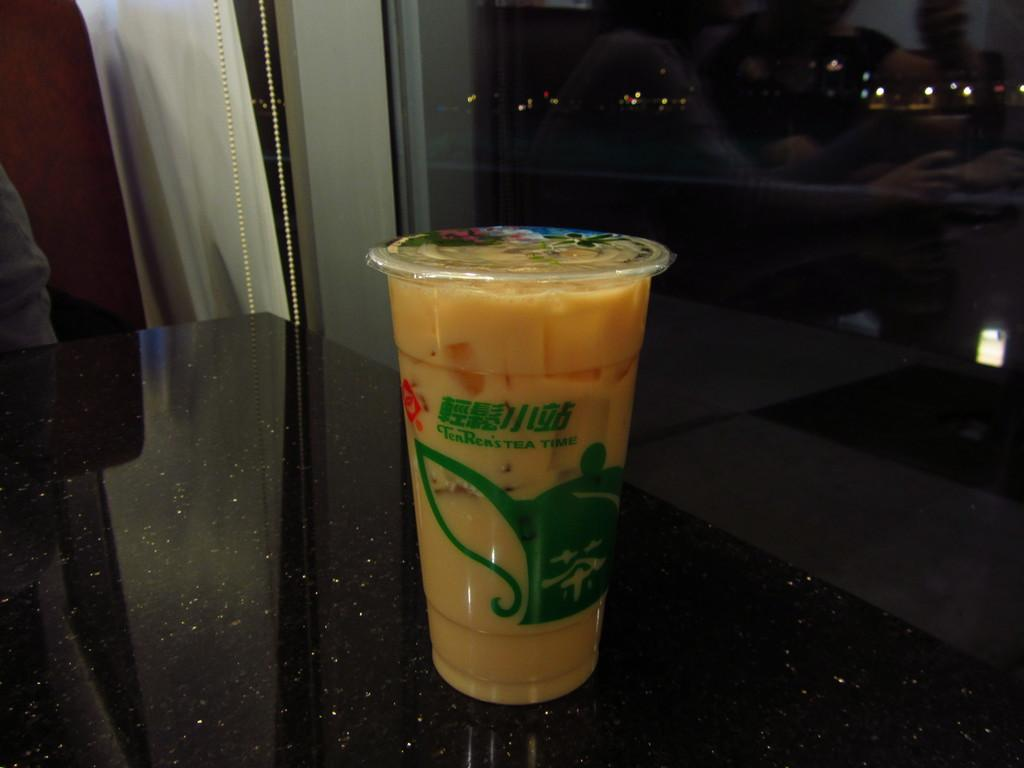What is on the black surface in the image? There is a glass on a black surface in the image. What is inside the glass? The glass contains a yellow liquid. Can you describe any other features of the image? There is a glass window visible in the image. What type of beef is being distributed through the glass window in the image? There is no beef or distribution process visible in the image; it only features a glass on a black surface and a glass window. 